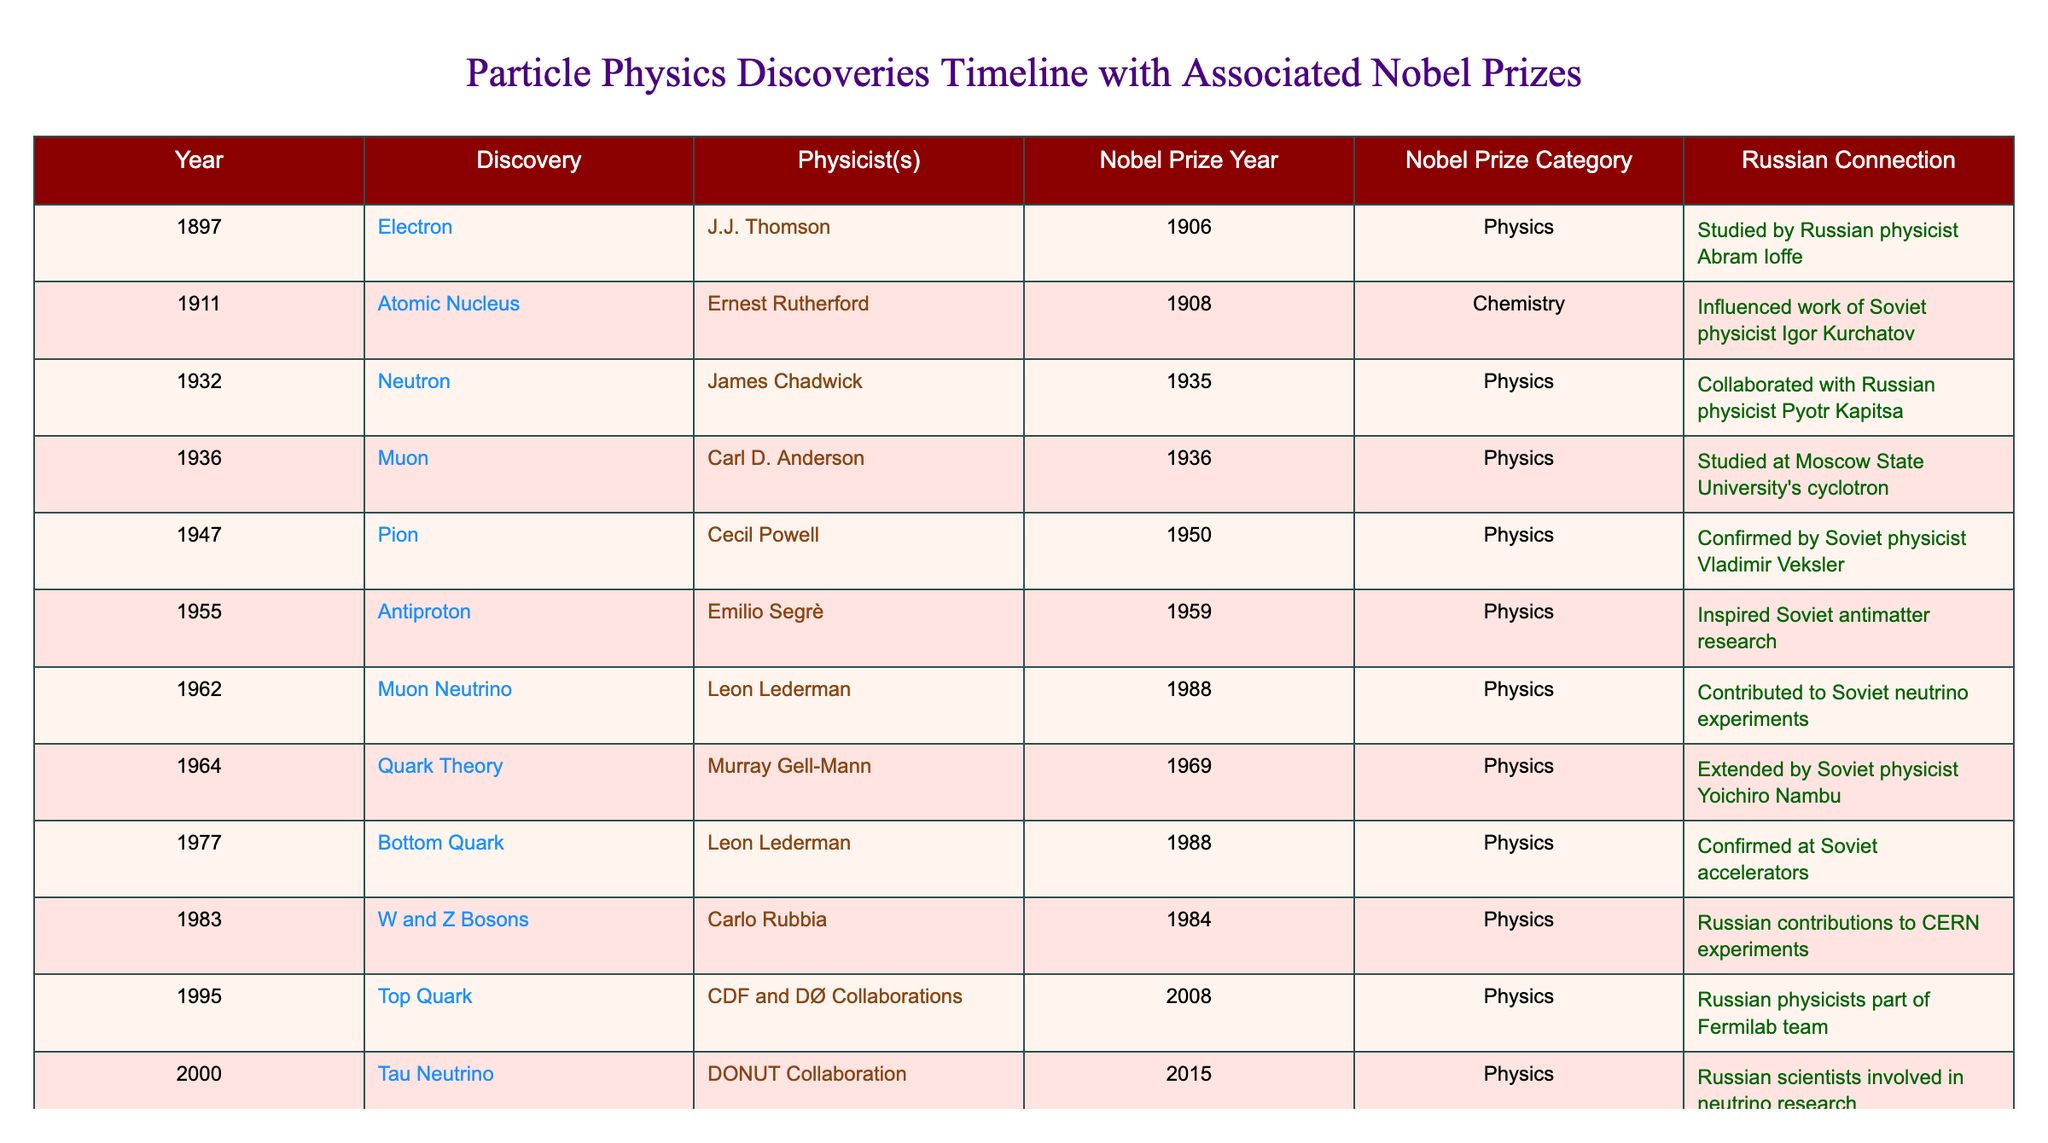What year was the Higgs Boson discovered? The table lists the discovery of the Higgs Boson in the year 2012.
Answer: 2012 Which discovery occurred in 1935? Referring to the table, the discovery in 1935 was the Neutron made by James Chadwick.
Answer: Neutron Who were the physicists associated with the discovery of the Top Quark? The table shows that both the CDF and DØ Collaborations are credited with the discovery of the Top Quark.
Answer: CDF and DØ Collaborations In what year did the physicist Carl D. Anderson receive recognition for the discovery of the Muon? According to the table, Carl D. Anderson was recognized in the year 1936 for the discovery of the Muon.
Answer: 1936 Which discovery was associated with the Russian physicist Vladimir Veksler? The table indicates that the Pion was confirmed by Vladimir Veksler in 1947.
Answer: Pion Is there a Nobel Prize associated with the discovery of the Electron? The table confirms that the discovery of the Electron by J.J. Thomson was awarded a Nobel Prize in 1906.
Answer: Yes How many discoveries were awarded the Nobel Prize in Physics between 1932 and 1964? From the table, there are three discoveries (Neutron, Muon, and Quark Theory) that received the Nobel Prize in Physics in that time frame.
Answer: 3 What is the Russian connection to the discovery of the W and Z Bosons? The table notes that Russian contributions were made to experimental work at CERN regarding the W and Z Bosons discovery.
Answer: Russian contributions to CERN experiments Which discovery listed has no associated Russian physicist in the connection? Reviewing the table, the discovery of the Bottom Quark does not list any associated Russian physicist in the connection.
Answer: Bottom Quark What is the difference in years between the discoveries of the Antiproton and the Top Quark? The table shows the Antiproton was discovered in 1955 and the Top Quark in 1995. The difference is 1995 - 1955 = 40 years.
Answer: 40 years What was the Nobel Prize year for the discovery of the Tau Neutrino? According to the table, the Nobel Prize for the Tau Neutrino discovery was awarded in 2015.
Answer: 2015 Who made the discovery of the W and Z Bosons and in what year? The table states that Carlo Rubbia discovered the W and Z Bosons in 1983.
Answer: Carlo Rubbia, 1983 Which discovery had collaborations from Russian physicists as part of its team? The table indicates that the discovery of the Top Quark involved Russian physicists as part of its Fermilab team.
Answer: Top Quark In what order occurred the discoveries from 1947 to 2000? From the table: Pion (1947), Antiproton (1955), Muon Neutrino (2000). Thus the chronological order is Pion, Antiproton, Muon Neutrino.
Answer: Pion, Antiproton, Muon Neutrino How many discoveries were made in the 1980s? The table shows two discoveries made in the 1980s: W and Z Bosons (1983) and Bottom Quark (1977). Therefore, the total is two discoveries made in or after 1980.
Answer: 2 